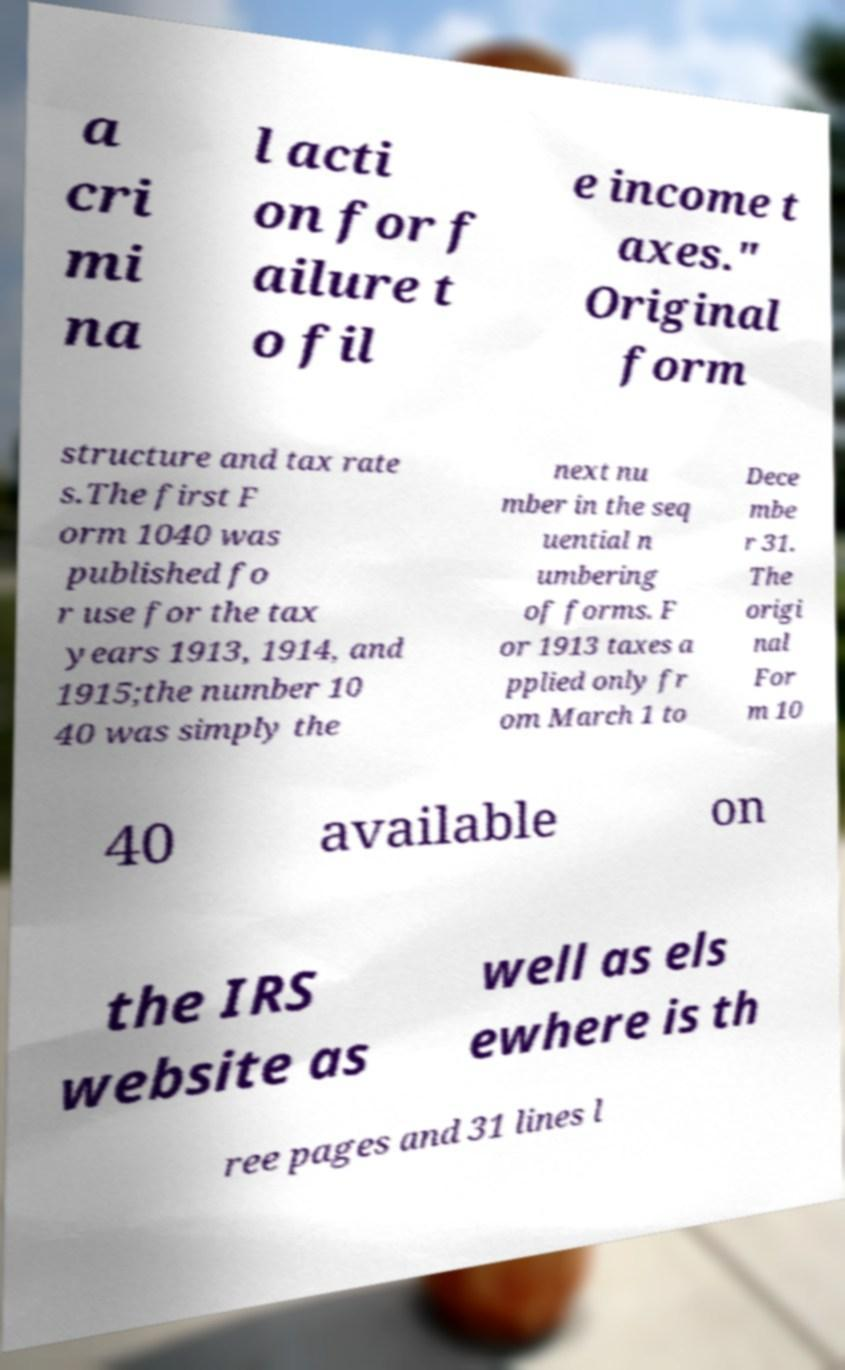Can you accurately transcribe the text from the provided image for me? a cri mi na l acti on for f ailure t o fil e income t axes." Original form structure and tax rate s.The first F orm 1040 was published fo r use for the tax years 1913, 1914, and 1915;the number 10 40 was simply the next nu mber in the seq uential n umbering of forms. F or 1913 taxes a pplied only fr om March 1 to Dece mbe r 31. The origi nal For m 10 40 available on the IRS website as well as els ewhere is th ree pages and 31 lines l 